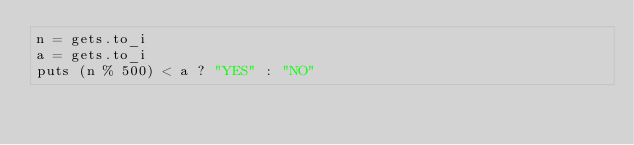Convert code to text. <code><loc_0><loc_0><loc_500><loc_500><_Ruby_>n = gets.to_i
a = gets.to_i
puts (n % 500) < a ? "YES" : "NO" </code> 